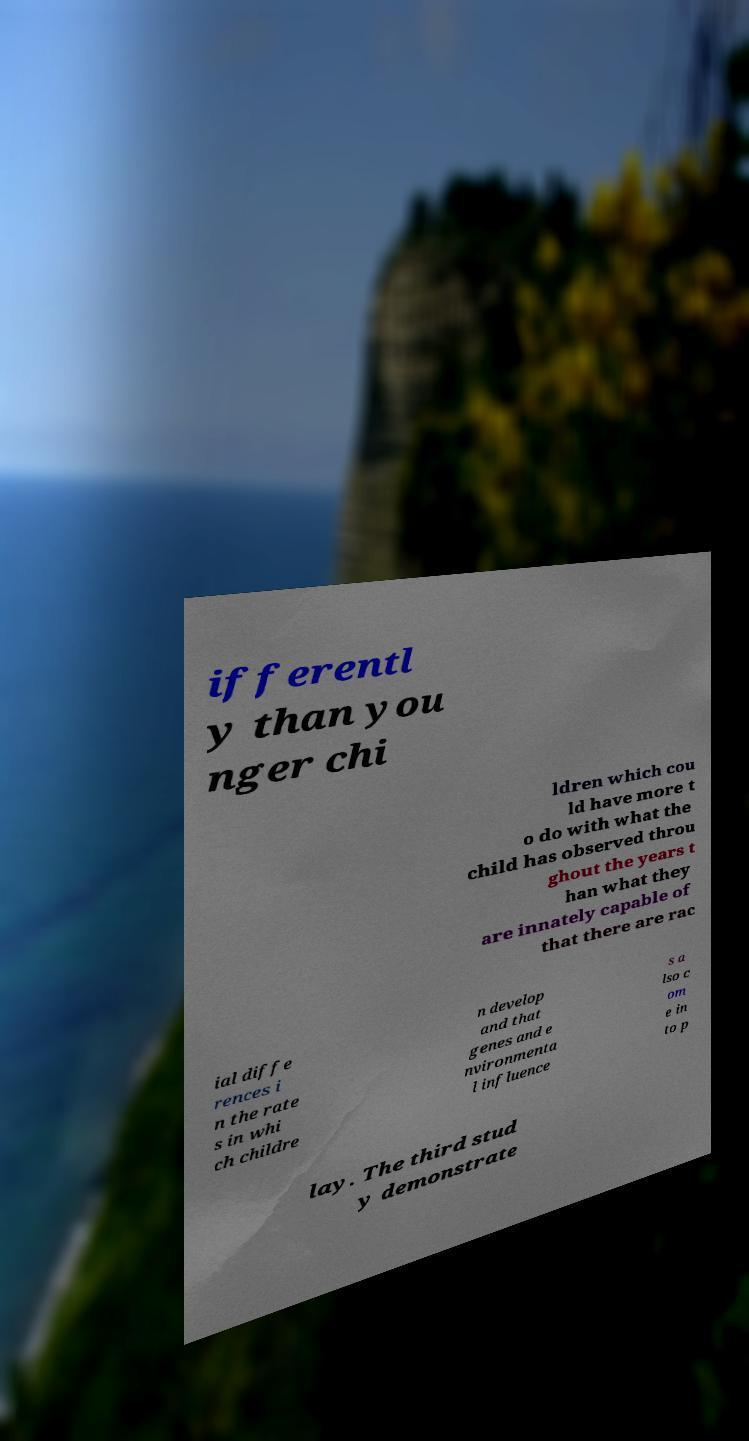Can you accurately transcribe the text from the provided image for me? ifferentl y than you nger chi ldren which cou ld have more t o do with what the child has observed throu ghout the years t han what they are innately capable of that there are rac ial diffe rences i n the rate s in whi ch childre n develop and that genes and e nvironmenta l influence s a lso c om e in to p lay. The third stud y demonstrate 